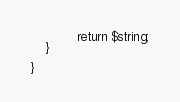<code> <loc_0><loc_0><loc_500><loc_500><_PHP_>            return $string;
    }

}
</code> 